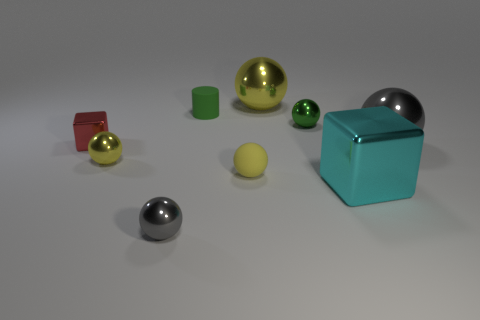There is a yellow metal object in front of the shiny thing that is to the right of the block in front of the tiny yellow matte thing; what is its size?
Your answer should be compact. Small. What number of other objects are there of the same material as the tiny cube?
Your answer should be very brief. 6. What is the size of the ball to the right of the tiny green metallic object?
Offer a very short reply. Large. How many shiny things are both behind the small red metal thing and to the left of the green shiny thing?
Offer a very short reply. 1. What material is the block that is on the left side of the gray ball in front of the tiny yellow rubber ball?
Your response must be concise. Metal. What material is the green object that is the same shape as the large gray thing?
Provide a succinct answer. Metal. Are any rubber cylinders visible?
Offer a terse response. Yes. There is a large yellow thing that is made of the same material as the big gray thing; what is its shape?
Offer a very short reply. Sphere. What is the material of the large ball that is in front of the large yellow object?
Provide a succinct answer. Metal. Does the large sphere that is to the right of the large cyan metal thing have the same color as the cylinder?
Provide a short and direct response. No. 